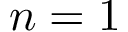Convert formula to latex. <formula><loc_0><loc_0><loc_500><loc_500>n = 1</formula> 